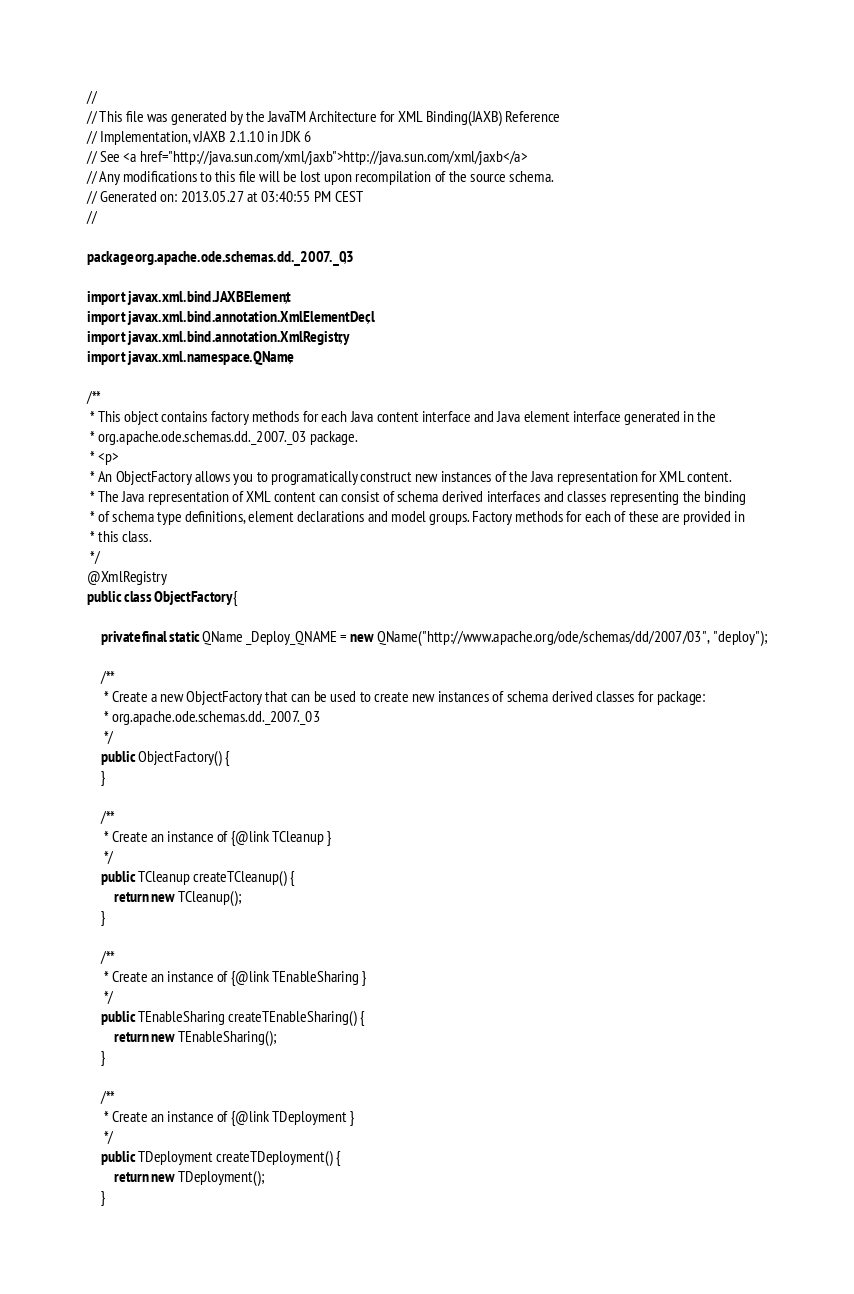<code> <loc_0><loc_0><loc_500><loc_500><_Java_>//
// This file was generated by the JavaTM Architecture for XML Binding(JAXB) Reference
// Implementation, vJAXB 2.1.10 in JDK 6
// See <a href="http://java.sun.com/xml/jaxb">http://java.sun.com/xml/jaxb</a>
// Any modifications to this file will be lost upon recompilation of the source schema.
// Generated on: 2013.05.27 at 03:40:55 PM CEST
//

package org.apache.ode.schemas.dd._2007._03;

import javax.xml.bind.JAXBElement;
import javax.xml.bind.annotation.XmlElementDecl;
import javax.xml.bind.annotation.XmlRegistry;
import javax.xml.namespace.QName;

/**
 * This object contains factory methods for each Java content interface and Java element interface generated in the
 * org.apache.ode.schemas.dd._2007._03 package.
 * <p>
 * An ObjectFactory allows you to programatically construct new instances of the Java representation for XML content.
 * The Java representation of XML content can consist of schema derived interfaces and classes representing the binding
 * of schema type definitions, element declarations and model groups. Factory methods for each of these are provided in
 * this class.
 */
@XmlRegistry
public class ObjectFactory {

    private final static QName _Deploy_QNAME = new QName("http://www.apache.org/ode/schemas/dd/2007/03", "deploy");

    /**
     * Create a new ObjectFactory that can be used to create new instances of schema derived classes for package:
     * org.apache.ode.schemas.dd._2007._03
     */
    public ObjectFactory() {
    }

    /**
     * Create an instance of {@link TCleanup }
     */
    public TCleanup createTCleanup() {
        return new TCleanup();
    }

    /**
     * Create an instance of {@link TEnableSharing }
     */
    public TEnableSharing createTEnableSharing() {
        return new TEnableSharing();
    }

    /**
     * Create an instance of {@link TDeployment }
     */
    public TDeployment createTDeployment() {
        return new TDeployment();
    }</code> 